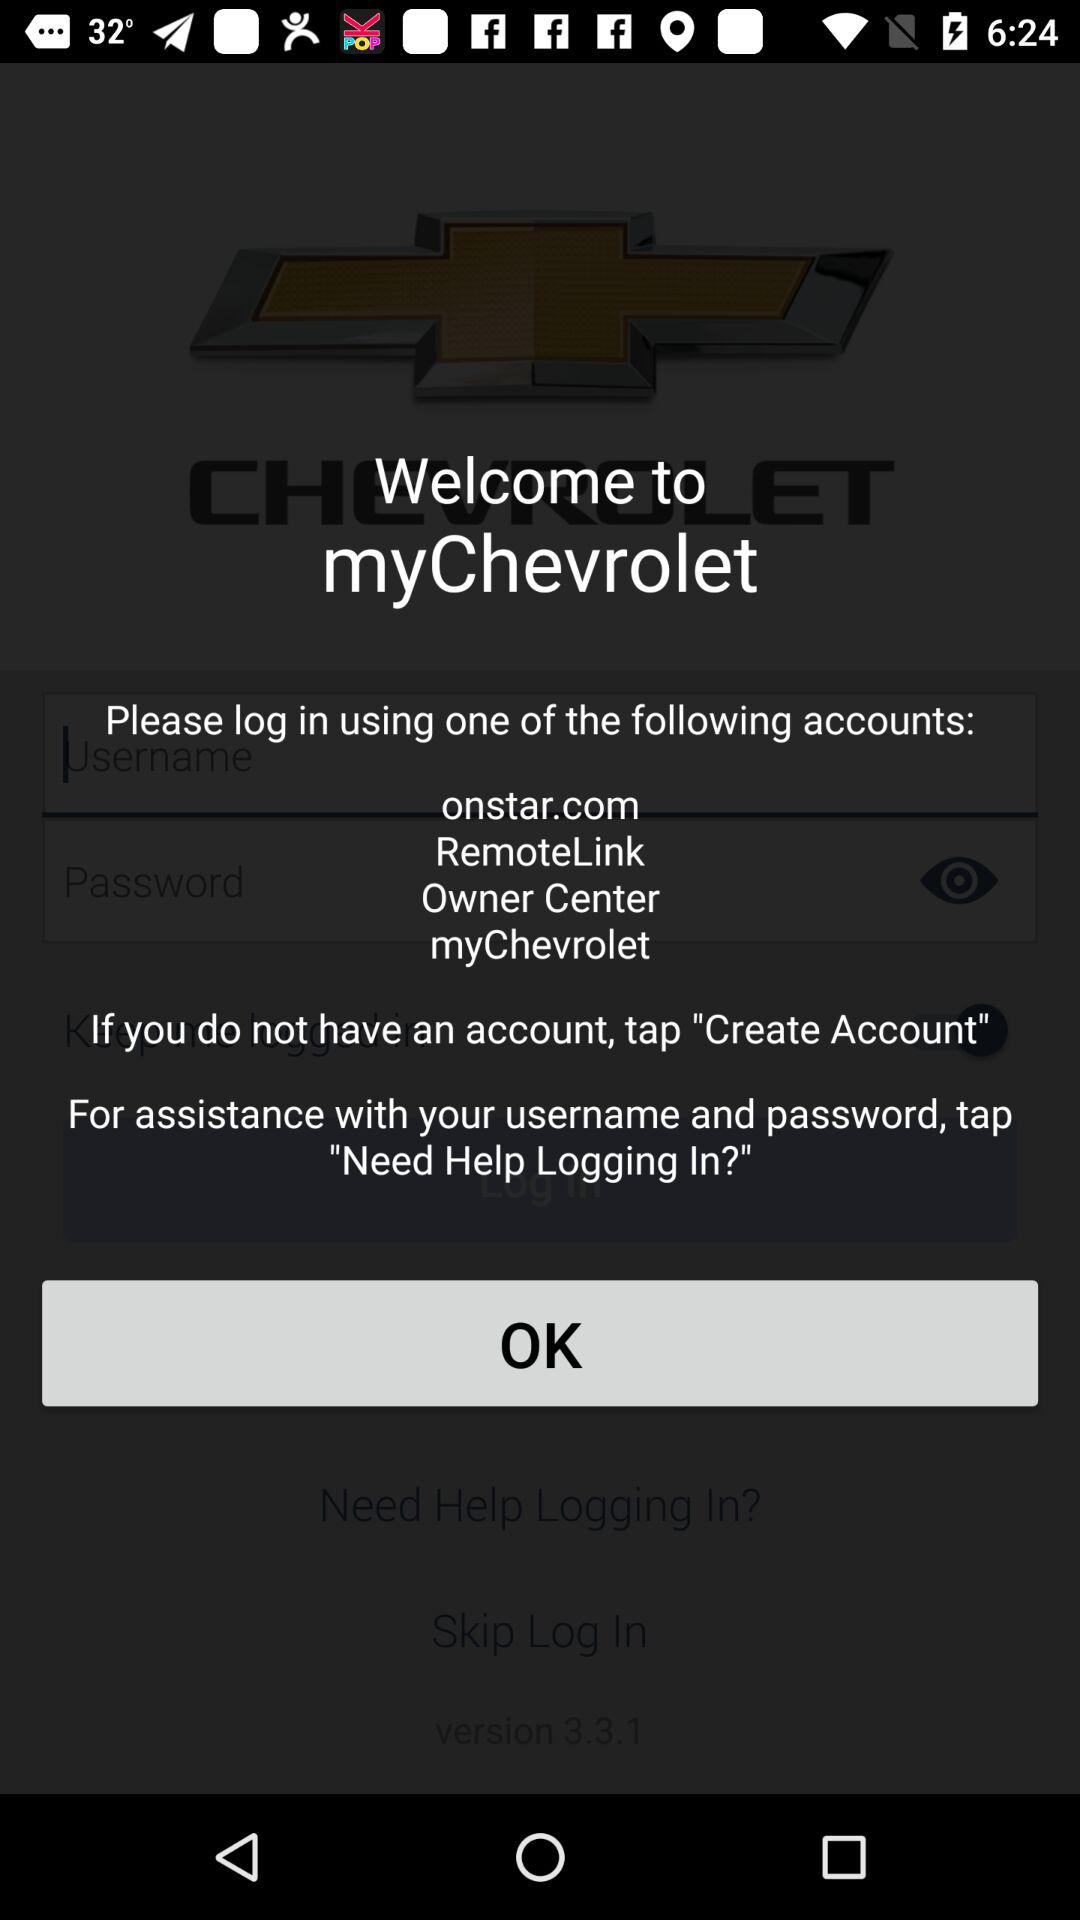What is the name of the application? The name of the application is "myChevrolet". 